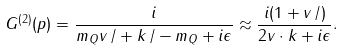<formula> <loc_0><loc_0><loc_500><loc_500>G ^ { ( 2 ) } ( p ) = \frac { i } { m _ { Q } v \, \slash + k \, \slash - m _ { Q } + i \epsilon } \approx \frac { i ( 1 + v \, \slash ) } { 2 v \cdot k + i \epsilon } .</formula> 